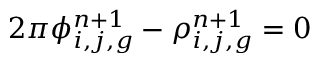<formula> <loc_0><loc_0><loc_500><loc_500>2 \pi \phi _ { i , j , g } ^ { n + 1 } - \rho _ { i , j , g } ^ { n + 1 } = 0</formula> 